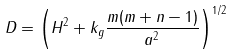<formula> <loc_0><loc_0><loc_500><loc_500>D = \left ( H ^ { 2 } + k _ { g } \frac { m ( m + n - 1 ) } { a ^ { 2 } } \right ) ^ { 1 / 2 }</formula> 